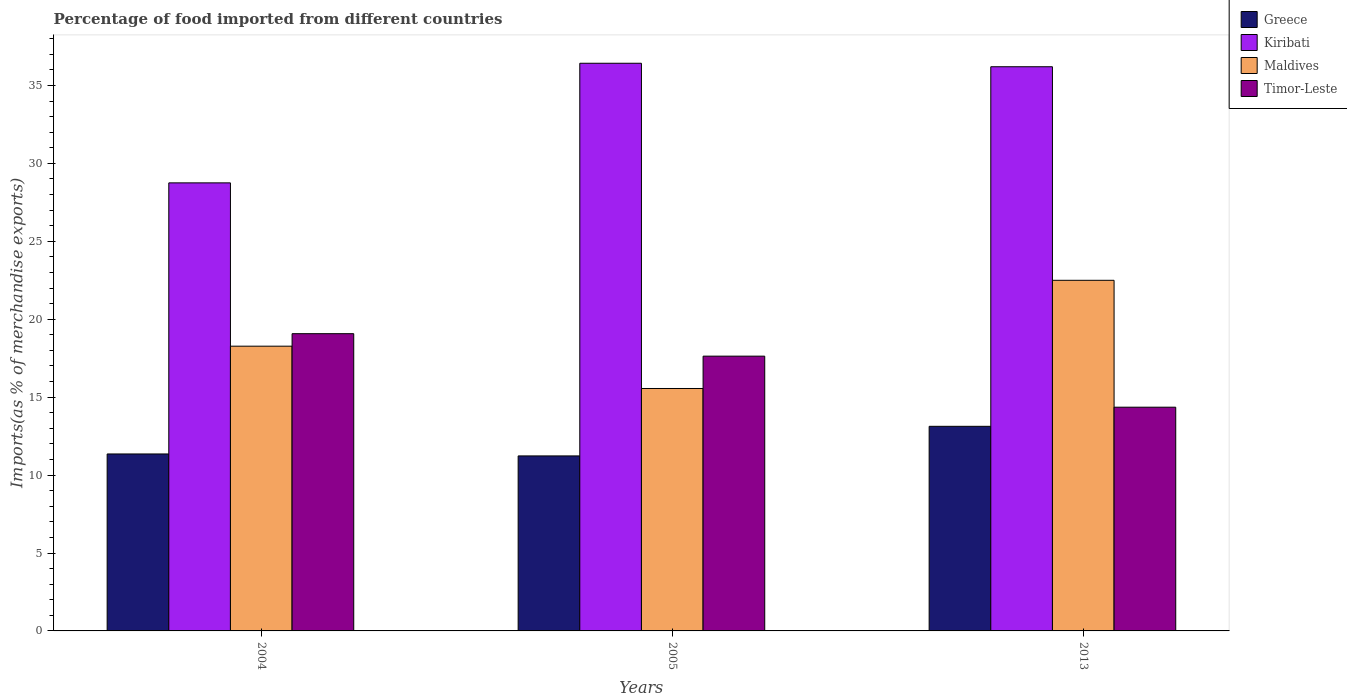What is the label of the 3rd group of bars from the left?
Offer a very short reply. 2013. In how many cases, is the number of bars for a given year not equal to the number of legend labels?
Your answer should be compact. 0. What is the percentage of imports to different countries in Kiribati in 2013?
Offer a very short reply. 36.2. Across all years, what is the maximum percentage of imports to different countries in Timor-Leste?
Your answer should be compact. 19.07. Across all years, what is the minimum percentage of imports to different countries in Kiribati?
Keep it short and to the point. 28.75. What is the total percentage of imports to different countries in Timor-Leste in the graph?
Provide a short and direct response. 51.06. What is the difference between the percentage of imports to different countries in Maldives in 2004 and that in 2005?
Your response must be concise. 2.72. What is the difference between the percentage of imports to different countries in Timor-Leste in 2013 and the percentage of imports to different countries in Kiribati in 2004?
Your response must be concise. -14.4. What is the average percentage of imports to different countries in Maldives per year?
Offer a terse response. 18.78. In the year 2005, what is the difference between the percentage of imports to different countries in Greece and percentage of imports to different countries in Timor-Leste?
Your answer should be compact. -6.4. In how many years, is the percentage of imports to different countries in Timor-Leste greater than 22 %?
Ensure brevity in your answer.  0. What is the ratio of the percentage of imports to different countries in Maldives in 2004 to that in 2005?
Ensure brevity in your answer.  1.17. Is the difference between the percentage of imports to different countries in Greece in 2004 and 2005 greater than the difference between the percentage of imports to different countries in Timor-Leste in 2004 and 2005?
Your answer should be compact. No. What is the difference between the highest and the second highest percentage of imports to different countries in Timor-Leste?
Offer a very short reply. 1.44. What is the difference between the highest and the lowest percentage of imports to different countries in Maldives?
Provide a short and direct response. 6.94. Is the sum of the percentage of imports to different countries in Kiribati in 2004 and 2013 greater than the maximum percentage of imports to different countries in Maldives across all years?
Make the answer very short. Yes. Is it the case that in every year, the sum of the percentage of imports to different countries in Kiribati and percentage of imports to different countries in Timor-Leste is greater than the sum of percentage of imports to different countries in Greece and percentage of imports to different countries in Maldives?
Your response must be concise. Yes. What does the 4th bar from the left in 2004 represents?
Your answer should be compact. Timor-Leste. What does the 2nd bar from the right in 2005 represents?
Your answer should be very brief. Maldives. Is it the case that in every year, the sum of the percentage of imports to different countries in Timor-Leste and percentage of imports to different countries in Kiribati is greater than the percentage of imports to different countries in Greece?
Offer a terse response. Yes. How many bars are there?
Your answer should be very brief. 12. Are all the bars in the graph horizontal?
Your answer should be compact. No. What is the difference between two consecutive major ticks on the Y-axis?
Your response must be concise. 5. Are the values on the major ticks of Y-axis written in scientific E-notation?
Ensure brevity in your answer.  No. Does the graph contain any zero values?
Your response must be concise. No. Where does the legend appear in the graph?
Keep it short and to the point. Top right. What is the title of the graph?
Give a very brief answer. Percentage of food imported from different countries. Does "Hong Kong" appear as one of the legend labels in the graph?
Offer a very short reply. No. What is the label or title of the X-axis?
Your answer should be very brief. Years. What is the label or title of the Y-axis?
Your answer should be very brief. Imports(as % of merchandise exports). What is the Imports(as % of merchandise exports) in Greece in 2004?
Provide a succinct answer. 11.36. What is the Imports(as % of merchandise exports) in Kiribati in 2004?
Give a very brief answer. 28.75. What is the Imports(as % of merchandise exports) of Maldives in 2004?
Ensure brevity in your answer.  18.27. What is the Imports(as % of merchandise exports) in Timor-Leste in 2004?
Your response must be concise. 19.07. What is the Imports(as % of merchandise exports) of Greece in 2005?
Ensure brevity in your answer.  11.23. What is the Imports(as % of merchandise exports) in Kiribati in 2005?
Offer a very short reply. 36.43. What is the Imports(as % of merchandise exports) in Maldives in 2005?
Offer a terse response. 15.56. What is the Imports(as % of merchandise exports) of Timor-Leste in 2005?
Offer a terse response. 17.63. What is the Imports(as % of merchandise exports) of Greece in 2013?
Keep it short and to the point. 13.13. What is the Imports(as % of merchandise exports) of Kiribati in 2013?
Give a very brief answer. 36.2. What is the Imports(as % of merchandise exports) of Maldives in 2013?
Your answer should be compact. 22.5. What is the Imports(as % of merchandise exports) of Timor-Leste in 2013?
Make the answer very short. 14.36. Across all years, what is the maximum Imports(as % of merchandise exports) in Greece?
Your answer should be compact. 13.13. Across all years, what is the maximum Imports(as % of merchandise exports) in Kiribati?
Provide a short and direct response. 36.43. Across all years, what is the maximum Imports(as % of merchandise exports) in Maldives?
Your response must be concise. 22.5. Across all years, what is the maximum Imports(as % of merchandise exports) of Timor-Leste?
Make the answer very short. 19.07. Across all years, what is the minimum Imports(as % of merchandise exports) in Greece?
Your response must be concise. 11.23. Across all years, what is the minimum Imports(as % of merchandise exports) in Kiribati?
Provide a succinct answer. 28.75. Across all years, what is the minimum Imports(as % of merchandise exports) of Maldives?
Make the answer very short. 15.56. Across all years, what is the minimum Imports(as % of merchandise exports) in Timor-Leste?
Give a very brief answer. 14.36. What is the total Imports(as % of merchandise exports) in Greece in the graph?
Make the answer very short. 35.71. What is the total Imports(as % of merchandise exports) of Kiribati in the graph?
Provide a succinct answer. 101.38. What is the total Imports(as % of merchandise exports) of Maldives in the graph?
Your response must be concise. 56.33. What is the total Imports(as % of merchandise exports) in Timor-Leste in the graph?
Offer a very short reply. 51.06. What is the difference between the Imports(as % of merchandise exports) of Greece in 2004 and that in 2005?
Your response must be concise. 0.13. What is the difference between the Imports(as % of merchandise exports) in Kiribati in 2004 and that in 2005?
Your response must be concise. -7.68. What is the difference between the Imports(as % of merchandise exports) of Maldives in 2004 and that in 2005?
Your response must be concise. 2.72. What is the difference between the Imports(as % of merchandise exports) of Timor-Leste in 2004 and that in 2005?
Make the answer very short. 1.44. What is the difference between the Imports(as % of merchandise exports) in Greece in 2004 and that in 2013?
Keep it short and to the point. -1.77. What is the difference between the Imports(as % of merchandise exports) in Kiribati in 2004 and that in 2013?
Provide a succinct answer. -7.45. What is the difference between the Imports(as % of merchandise exports) in Maldives in 2004 and that in 2013?
Offer a very short reply. -4.23. What is the difference between the Imports(as % of merchandise exports) in Timor-Leste in 2004 and that in 2013?
Your response must be concise. 4.72. What is the difference between the Imports(as % of merchandise exports) of Greece in 2005 and that in 2013?
Make the answer very short. -1.9. What is the difference between the Imports(as % of merchandise exports) of Kiribati in 2005 and that in 2013?
Ensure brevity in your answer.  0.22. What is the difference between the Imports(as % of merchandise exports) in Maldives in 2005 and that in 2013?
Your answer should be very brief. -6.94. What is the difference between the Imports(as % of merchandise exports) in Timor-Leste in 2005 and that in 2013?
Give a very brief answer. 3.28. What is the difference between the Imports(as % of merchandise exports) of Greece in 2004 and the Imports(as % of merchandise exports) of Kiribati in 2005?
Keep it short and to the point. -25.07. What is the difference between the Imports(as % of merchandise exports) in Greece in 2004 and the Imports(as % of merchandise exports) in Maldives in 2005?
Your answer should be very brief. -4.2. What is the difference between the Imports(as % of merchandise exports) of Greece in 2004 and the Imports(as % of merchandise exports) of Timor-Leste in 2005?
Provide a succinct answer. -6.28. What is the difference between the Imports(as % of merchandise exports) of Kiribati in 2004 and the Imports(as % of merchandise exports) of Maldives in 2005?
Provide a short and direct response. 13.2. What is the difference between the Imports(as % of merchandise exports) in Kiribati in 2004 and the Imports(as % of merchandise exports) in Timor-Leste in 2005?
Keep it short and to the point. 11.12. What is the difference between the Imports(as % of merchandise exports) in Maldives in 2004 and the Imports(as % of merchandise exports) in Timor-Leste in 2005?
Ensure brevity in your answer.  0.64. What is the difference between the Imports(as % of merchandise exports) in Greece in 2004 and the Imports(as % of merchandise exports) in Kiribati in 2013?
Your response must be concise. -24.85. What is the difference between the Imports(as % of merchandise exports) in Greece in 2004 and the Imports(as % of merchandise exports) in Maldives in 2013?
Provide a succinct answer. -11.14. What is the difference between the Imports(as % of merchandise exports) in Greece in 2004 and the Imports(as % of merchandise exports) in Timor-Leste in 2013?
Your response must be concise. -3. What is the difference between the Imports(as % of merchandise exports) in Kiribati in 2004 and the Imports(as % of merchandise exports) in Maldives in 2013?
Your answer should be compact. 6.25. What is the difference between the Imports(as % of merchandise exports) of Kiribati in 2004 and the Imports(as % of merchandise exports) of Timor-Leste in 2013?
Provide a succinct answer. 14.4. What is the difference between the Imports(as % of merchandise exports) in Maldives in 2004 and the Imports(as % of merchandise exports) in Timor-Leste in 2013?
Offer a terse response. 3.92. What is the difference between the Imports(as % of merchandise exports) of Greece in 2005 and the Imports(as % of merchandise exports) of Kiribati in 2013?
Offer a terse response. -24.97. What is the difference between the Imports(as % of merchandise exports) in Greece in 2005 and the Imports(as % of merchandise exports) in Maldives in 2013?
Your answer should be very brief. -11.27. What is the difference between the Imports(as % of merchandise exports) in Greece in 2005 and the Imports(as % of merchandise exports) in Timor-Leste in 2013?
Ensure brevity in your answer.  -3.13. What is the difference between the Imports(as % of merchandise exports) in Kiribati in 2005 and the Imports(as % of merchandise exports) in Maldives in 2013?
Provide a succinct answer. 13.93. What is the difference between the Imports(as % of merchandise exports) in Kiribati in 2005 and the Imports(as % of merchandise exports) in Timor-Leste in 2013?
Your answer should be very brief. 22.07. What is the average Imports(as % of merchandise exports) of Greece per year?
Provide a short and direct response. 11.9. What is the average Imports(as % of merchandise exports) in Kiribati per year?
Provide a short and direct response. 33.79. What is the average Imports(as % of merchandise exports) of Maldives per year?
Your answer should be compact. 18.78. What is the average Imports(as % of merchandise exports) in Timor-Leste per year?
Offer a very short reply. 17.02. In the year 2004, what is the difference between the Imports(as % of merchandise exports) in Greece and Imports(as % of merchandise exports) in Kiribati?
Offer a very short reply. -17.4. In the year 2004, what is the difference between the Imports(as % of merchandise exports) of Greece and Imports(as % of merchandise exports) of Maldives?
Your answer should be compact. -6.92. In the year 2004, what is the difference between the Imports(as % of merchandise exports) in Greece and Imports(as % of merchandise exports) in Timor-Leste?
Your answer should be compact. -7.72. In the year 2004, what is the difference between the Imports(as % of merchandise exports) in Kiribati and Imports(as % of merchandise exports) in Maldives?
Make the answer very short. 10.48. In the year 2004, what is the difference between the Imports(as % of merchandise exports) in Kiribati and Imports(as % of merchandise exports) in Timor-Leste?
Your answer should be compact. 9.68. In the year 2004, what is the difference between the Imports(as % of merchandise exports) in Maldives and Imports(as % of merchandise exports) in Timor-Leste?
Offer a very short reply. -0.8. In the year 2005, what is the difference between the Imports(as % of merchandise exports) of Greece and Imports(as % of merchandise exports) of Kiribati?
Your answer should be compact. -25.2. In the year 2005, what is the difference between the Imports(as % of merchandise exports) of Greece and Imports(as % of merchandise exports) of Maldives?
Your response must be concise. -4.33. In the year 2005, what is the difference between the Imports(as % of merchandise exports) of Greece and Imports(as % of merchandise exports) of Timor-Leste?
Make the answer very short. -6.4. In the year 2005, what is the difference between the Imports(as % of merchandise exports) of Kiribati and Imports(as % of merchandise exports) of Maldives?
Make the answer very short. 20.87. In the year 2005, what is the difference between the Imports(as % of merchandise exports) in Kiribati and Imports(as % of merchandise exports) in Timor-Leste?
Give a very brief answer. 18.8. In the year 2005, what is the difference between the Imports(as % of merchandise exports) of Maldives and Imports(as % of merchandise exports) of Timor-Leste?
Provide a short and direct response. -2.08. In the year 2013, what is the difference between the Imports(as % of merchandise exports) of Greece and Imports(as % of merchandise exports) of Kiribati?
Keep it short and to the point. -23.07. In the year 2013, what is the difference between the Imports(as % of merchandise exports) of Greece and Imports(as % of merchandise exports) of Maldives?
Offer a terse response. -9.37. In the year 2013, what is the difference between the Imports(as % of merchandise exports) of Greece and Imports(as % of merchandise exports) of Timor-Leste?
Give a very brief answer. -1.23. In the year 2013, what is the difference between the Imports(as % of merchandise exports) in Kiribati and Imports(as % of merchandise exports) in Maldives?
Provide a succinct answer. 13.7. In the year 2013, what is the difference between the Imports(as % of merchandise exports) of Kiribati and Imports(as % of merchandise exports) of Timor-Leste?
Make the answer very short. 21.85. In the year 2013, what is the difference between the Imports(as % of merchandise exports) in Maldives and Imports(as % of merchandise exports) in Timor-Leste?
Make the answer very short. 8.14. What is the ratio of the Imports(as % of merchandise exports) of Greece in 2004 to that in 2005?
Offer a very short reply. 1.01. What is the ratio of the Imports(as % of merchandise exports) of Kiribati in 2004 to that in 2005?
Keep it short and to the point. 0.79. What is the ratio of the Imports(as % of merchandise exports) in Maldives in 2004 to that in 2005?
Offer a terse response. 1.17. What is the ratio of the Imports(as % of merchandise exports) of Timor-Leste in 2004 to that in 2005?
Your answer should be very brief. 1.08. What is the ratio of the Imports(as % of merchandise exports) in Greece in 2004 to that in 2013?
Provide a short and direct response. 0.86. What is the ratio of the Imports(as % of merchandise exports) in Kiribati in 2004 to that in 2013?
Provide a succinct answer. 0.79. What is the ratio of the Imports(as % of merchandise exports) of Maldives in 2004 to that in 2013?
Your answer should be compact. 0.81. What is the ratio of the Imports(as % of merchandise exports) in Timor-Leste in 2004 to that in 2013?
Your response must be concise. 1.33. What is the ratio of the Imports(as % of merchandise exports) in Greece in 2005 to that in 2013?
Offer a terse response. 0.86. What is the ratio of the Imports(as % of merchandise exports) in Kiribati in 2005 to that in 2013?
Offer a very short reply. 1.01. What is the ratio of the Imports(as % of merchandise exports) of Maldives in 2005 to that in 2013?
Keep it short and to the point. 0.69. What is the ratio of the Imports(as % of merchandise exports) in Timor-Leste in 2005 to that in 2013?
Offer a very short reply. 1.23. What is the difference between the highest and the second highest Imports(as % of merchandise exports) in Greece?
Your answer should be compact. 1.77. What is the difference between the highest and the second highest Imports(as % of merchandise exports) in Kiribati?
Offer a terse response. 0.22. What is the difference between the highest and the second highest Imports(as % of merchandise exports) in Maldives?
Offer a terse response. 4.23. What is the difference between the highest and the second highest Imports(as % of merchandise exports) of Timor-Leste?
Give a very brief answer. 1.44. What is the difference between the highest and the lowest Imports(as % of merchandise exports) of Greece?
Give a very brief answer. 1.9. What is the difference between the highest and the lowest Imports(as % of merchandise exports) in Kiribati?
Your response must be concise. 7.68. What is the difference between the highest and the lowest Imports(as % of merchandise exports) in Maldives?
Your answer should be compact. 6.94. What is the difference between the highest and the lowest Imports(as % of merchandise exports) in Timor-Leste?
Offer a terse response. 4.72. 